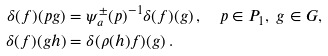Convert formula to latex. <formula><loc_0><loc_0><loc_500><loc_500>\delta ( f ) ( p g ) & = \psi _ { a } ^ { \pm } ( p ) ^ { - 1 } { \delta ( f ) } ( g ) \, , \quad p \in P _ { 1 } , \ g \in G , \\ \delta ( f ) ( g h ) & = \delta ( \rho ( h ) f ) ( g ) \, .</formula> 